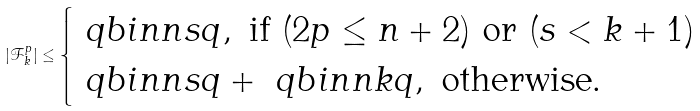Convert formula to latex. <formula><loc_0><loc_0><loc_500><loc_500>| \mathcal { F } _ { k } ^ { p } | \leq \begin{cases} \ q b i n { n } { s } { q } , \text { if } ( 2 p \leq n + 2 ) \text { or } ( s < k + 1 ) \\ \ q b i n { n } { s } { q } + \ q b i n { n } { k } { q } , \text { otherwise.} \end{cases}</formula> 